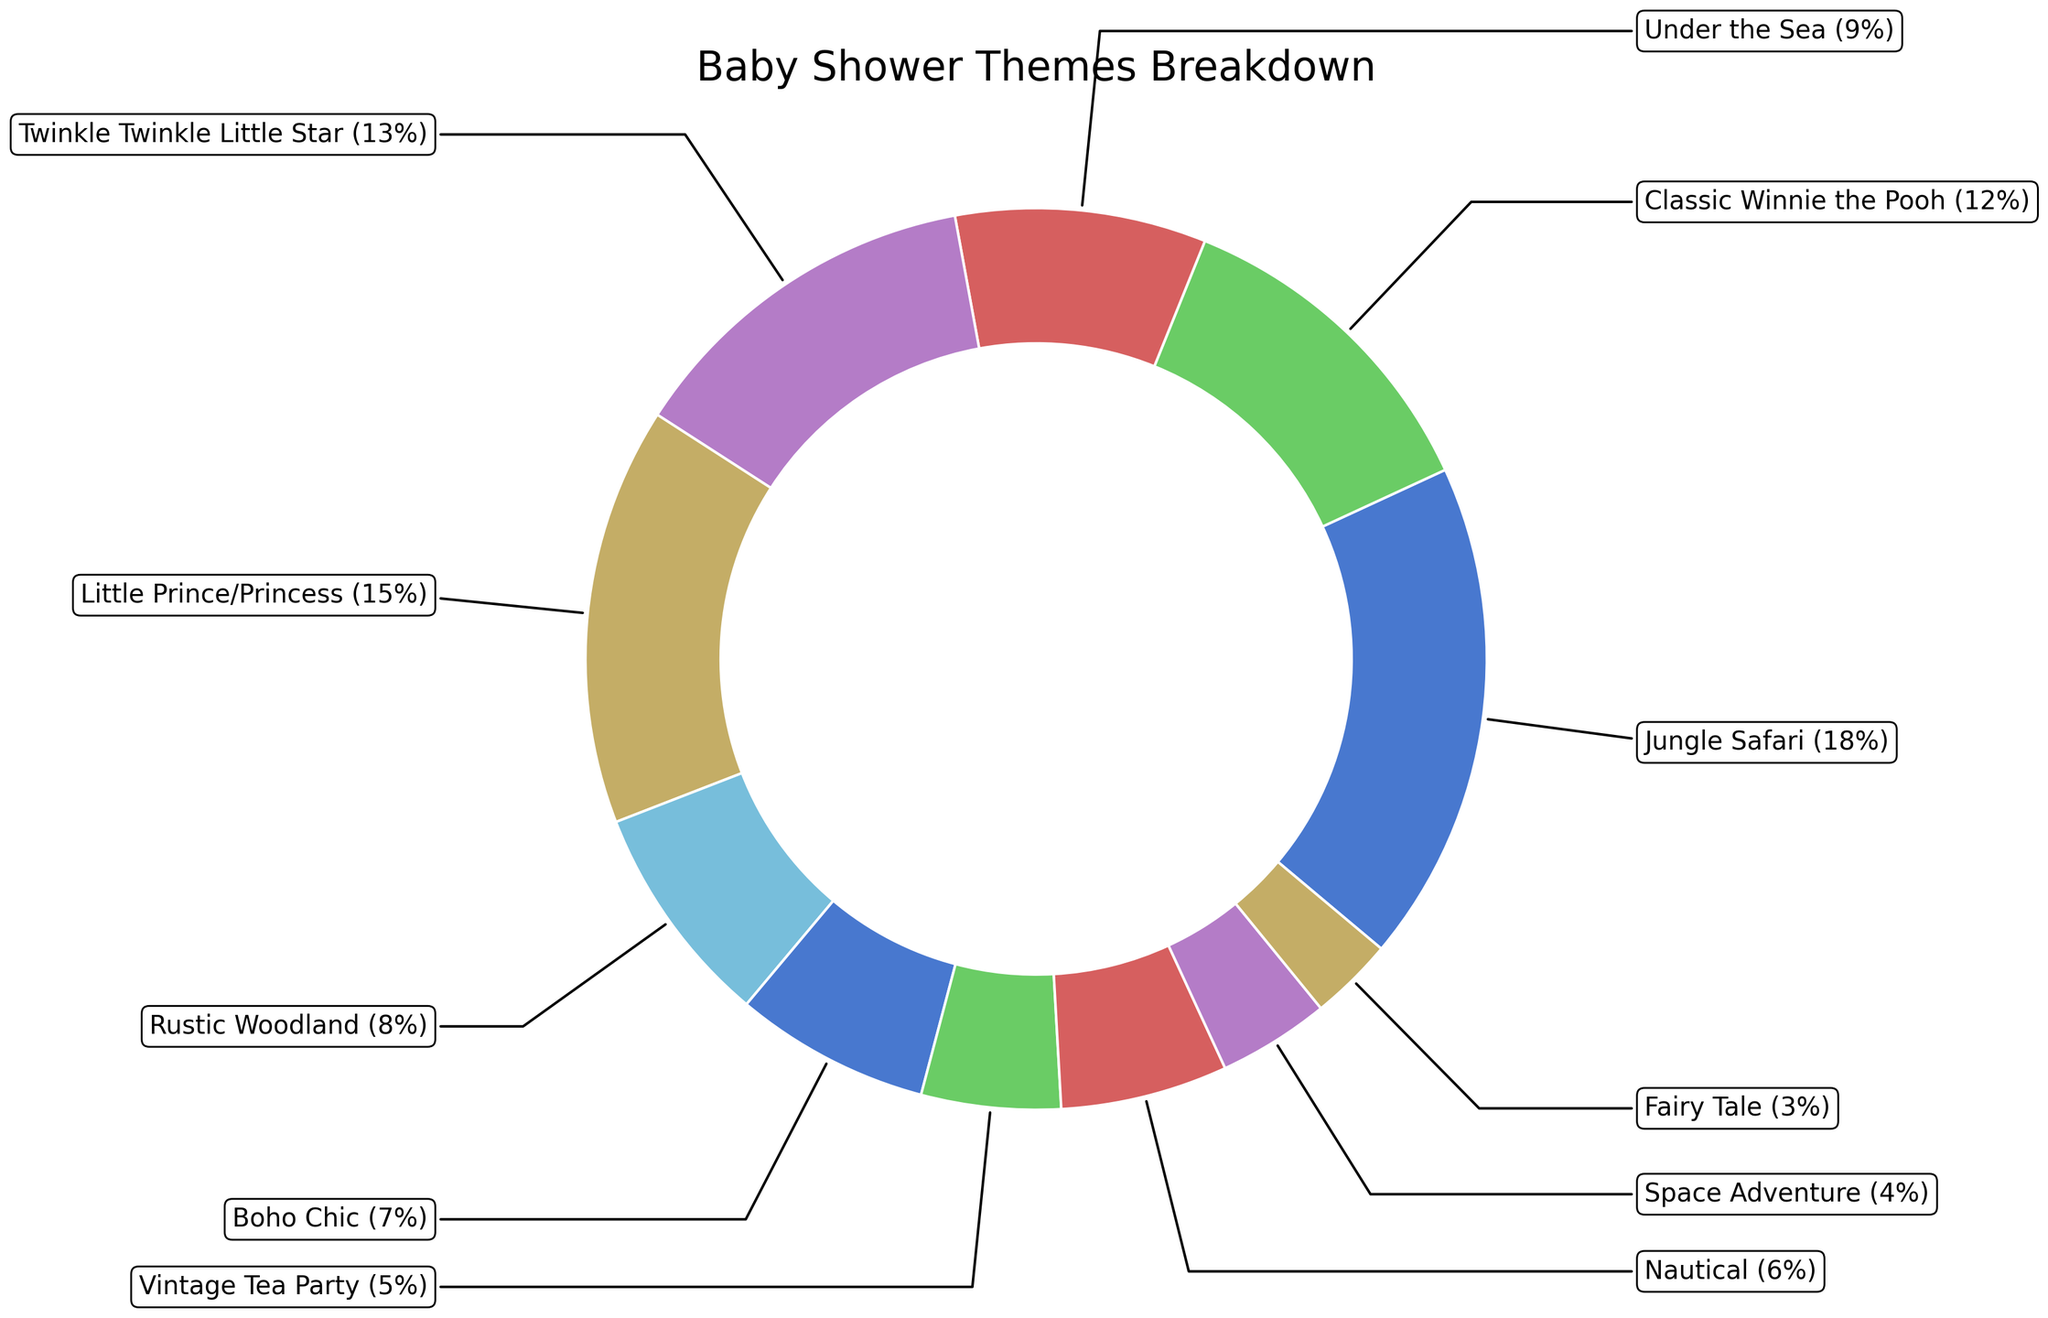Which baby shower theme is the most popular? The wedge with the largest percentage represents the most popular theme. 'Jungle Safari' at 18% is the largest segment.
Answer: Jungle Safari Which baby shower theme is the least popular? The smallest wedge represents the least popular theme. 'Fairy Tale' has the smallest segment at 3%.
Answer: Fairy Tale How many themes have a percentage greater than 10%? Identify all wedges with percentages greater than 10%. There are four such wedges: Jungle Safari (18%), Classic Winnie the Pooh (12%), Twinkle Twinkle Little Star (13%), and Little Prince/Princess (15%).
Answer: 4 What's the combined percentage of 'Boho Chic' and 'Vintage Tea Party' themes? Add the percentages of the two specified themes: Boho Chic (7%) + Vintage Tea Party (5%) = 12%.
Answer: 12% Which theme is more popular: 'Space Adventure' or 'Nautical'? Compare the percentages of the two specified themes. Nautical (6%) is larger than Space Adventure (4%).
Answer: Nautical What's the difference in percentage between 'Jungle Safari' and 'Fairy Tale'? Subtract the percentage of 'Fairy Tale' from 'Jungle Safari': 18% - 3% = 15%.
Answer: 15% What's the average percentage of all themes in the chart? Sum all percentages and divide by the number of themes: (18 + 12 + 9 + 13 + 15 + 8 + 7 + 5 + 6 + 4 + 3) / 11 = 100 / 11 ≈ 9.09%.
Answer: 9.09% Which theme has a percentage closest to the average percentage of all themes? Calculate the average (9.09%) and find the theme with a percentage closest to this value. 'Under the Sea' has exactly 9%.
Answer: Under the Sea 